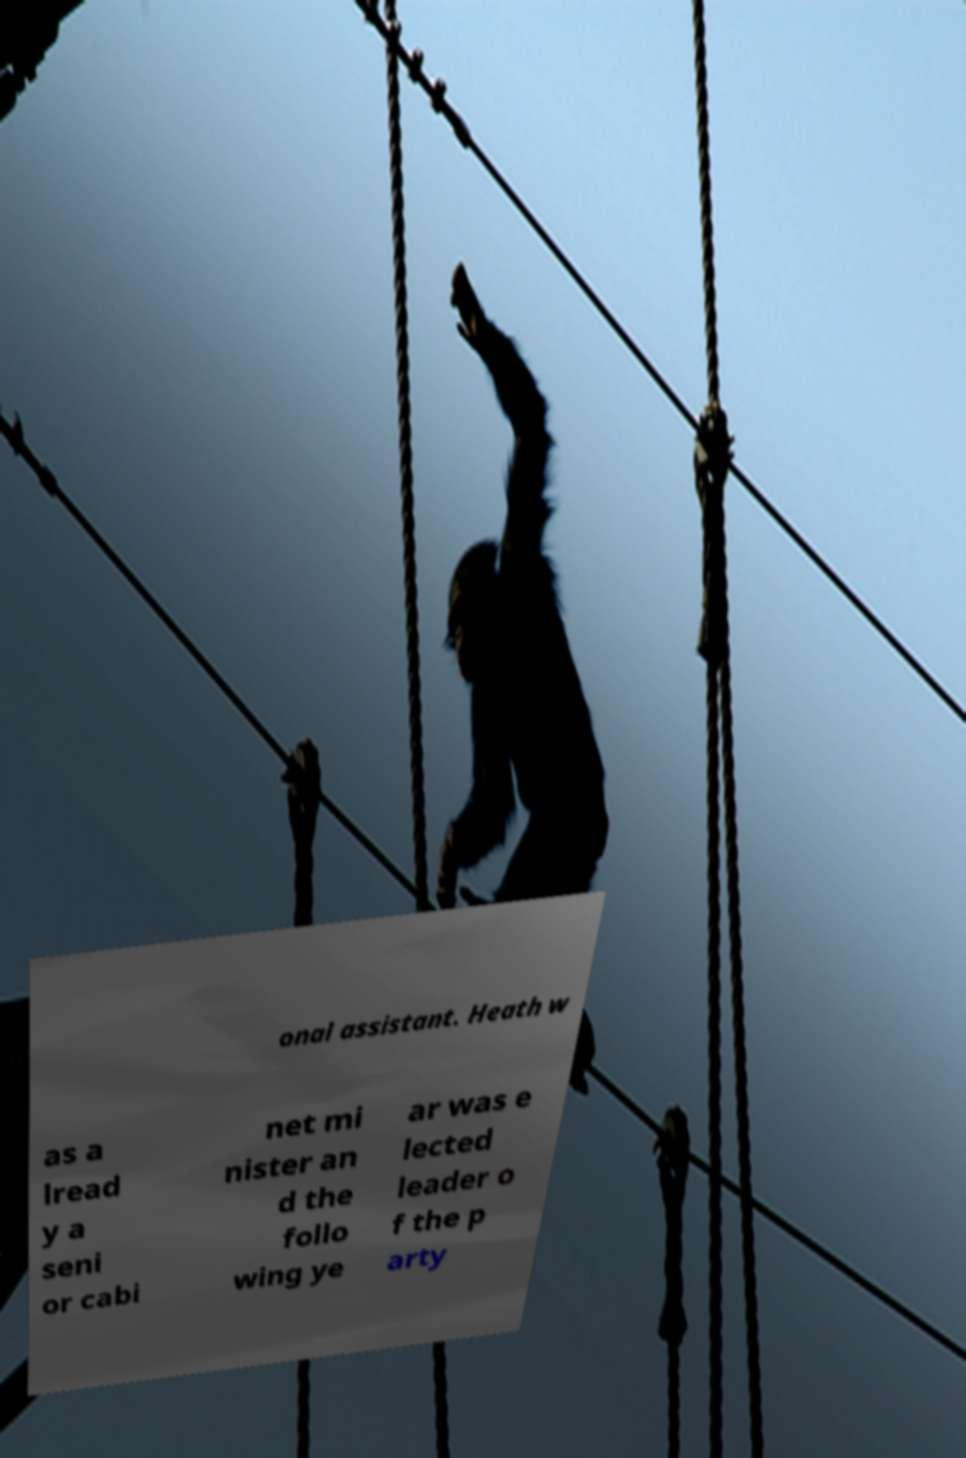There's text embedded in this image that I need extracted. Can you transcribe it verbatim? onal assistant. Heath w as a lread y a seni or cabi net mi nister an d the follo wing ye ar was e lected leader o f the p arty 